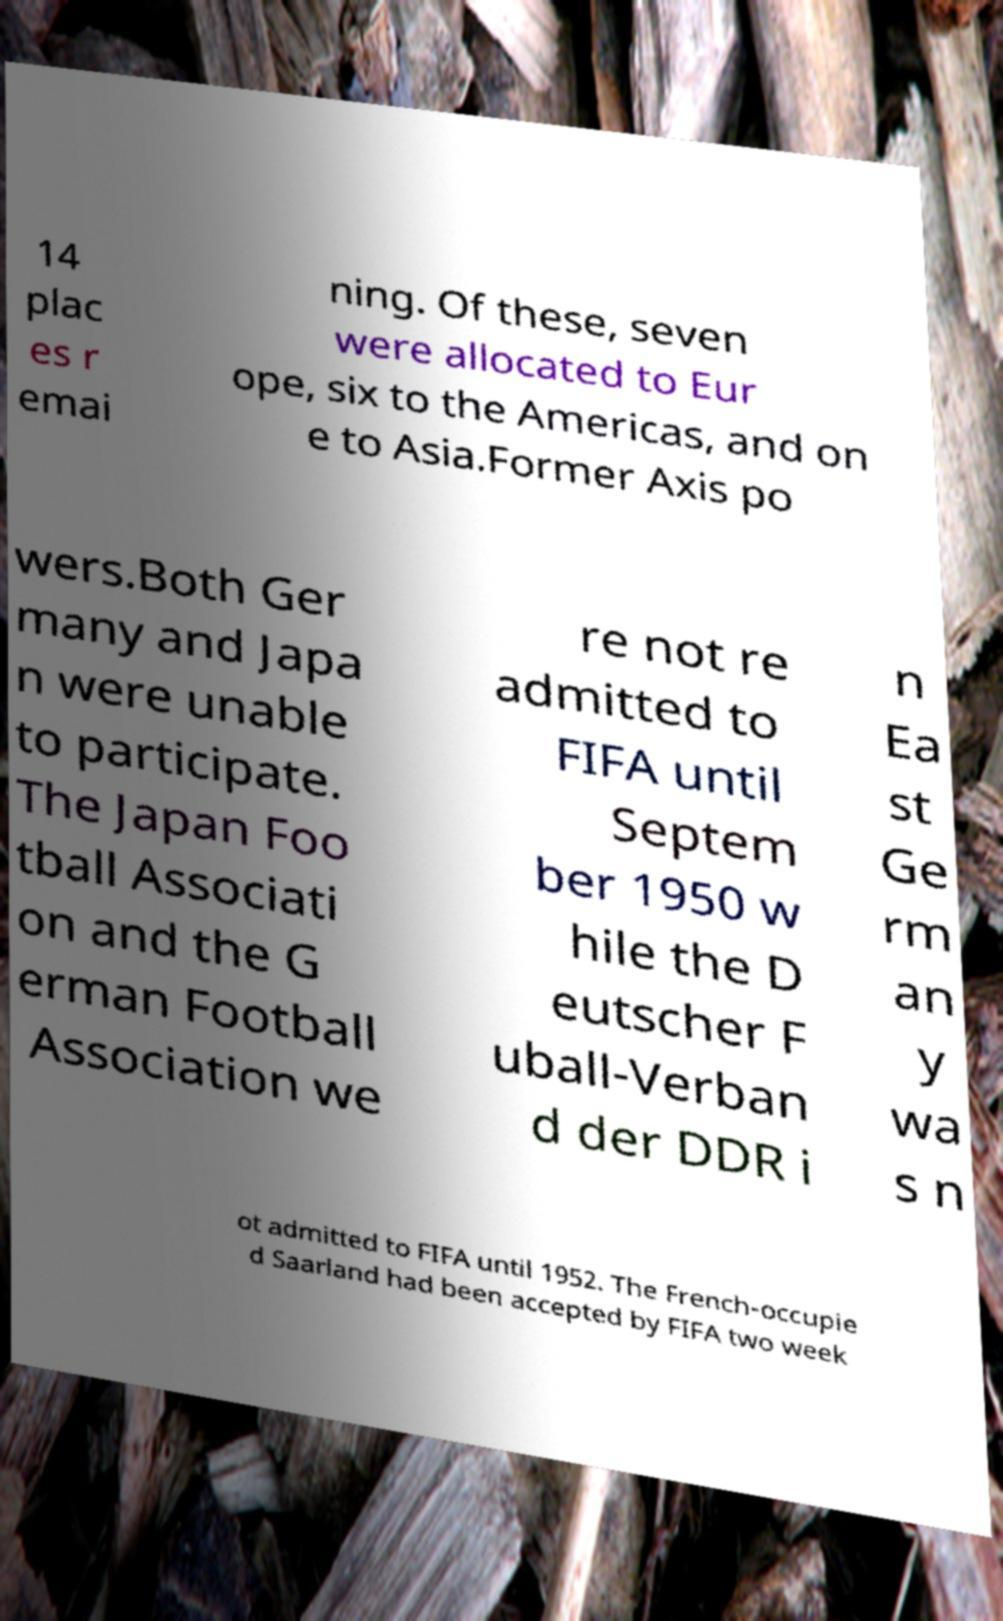Can you accurately transcribe the text from the provided image for me? 14 plac es r emai ning. Of these, seven were allocated to Eur ope, six to the Americas, and on e to Asia.Former Axis po wers.Both Ger many and Japa n were unable to participate. The Japan Foo tball Associati on and the G erman Football Association we re not re admitted to FIFA until Septem ber 1950 w hile the D eutscher F uball-Verban d der DDR i n Ea st Ge rm an y wa s n ot admitted to FIFA until 1952. The French-occupie d Saarland had been accepted by FIFA two week 